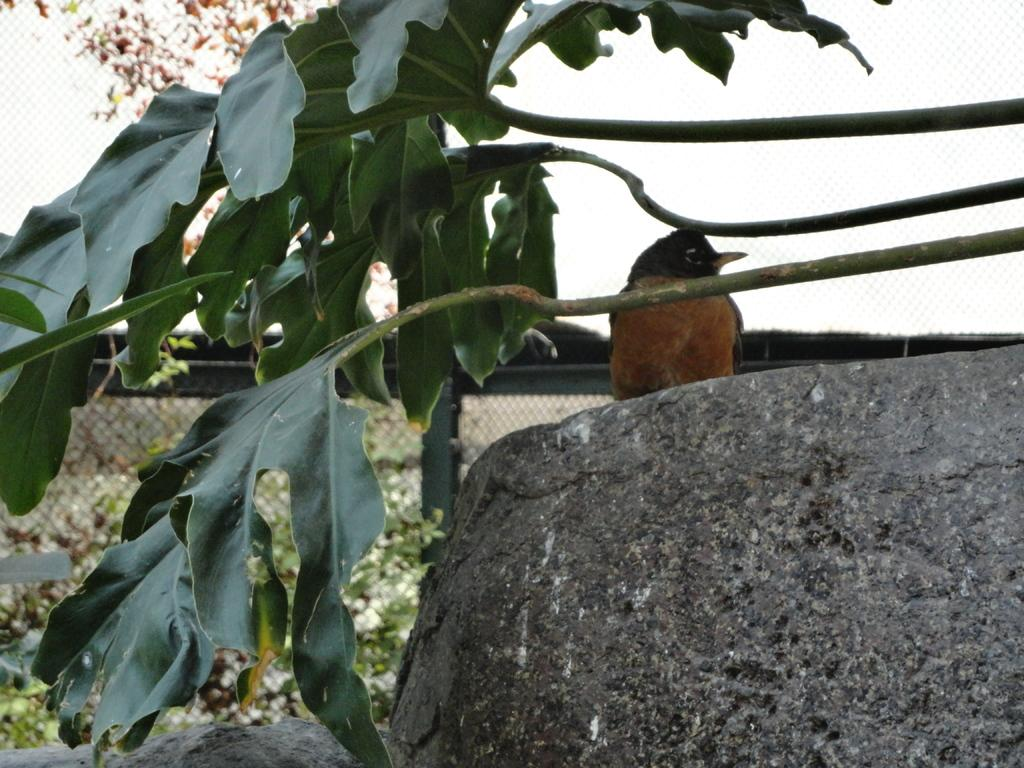What animal can be seen in the image? There is a bird in the image. Where is the bird located? The bird is sitting on a rock. What type of vegetation is present in the image? There are leaves in the image. What can be seen in the background of the image? There is a fencing and a plant in the background of the image. What type of cup is being used in the war depicted in the image? There is no war or cup present in the image; it features a bird sitting on a rock with leaves, fencing, and a plant in the background. 